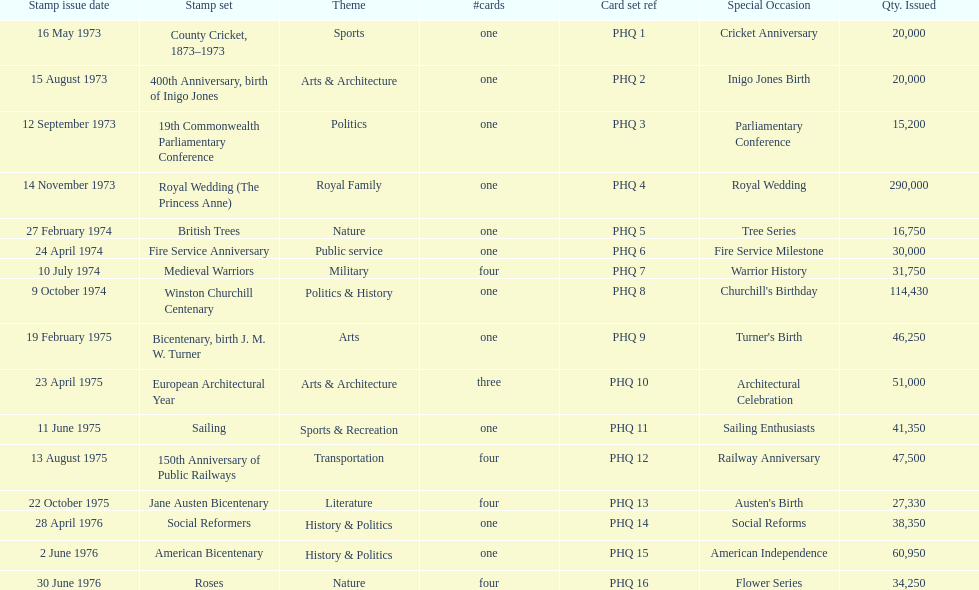How many stamp sets had at least 50,000 issued? 4. 